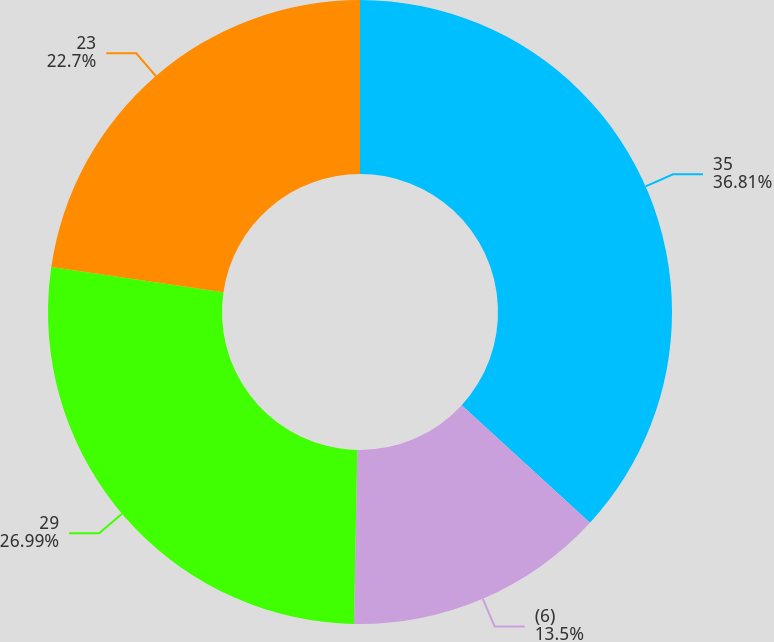<chart> <loc_0><loc_0><loc_500><loc_500><pie_chart><fcel>35<fcel>(6)<fcel>29<fcel>23<nl><fcel>36.81%<fcel>13.5%<fcel>26.99%<fcel>22.7%<nl></chart> 